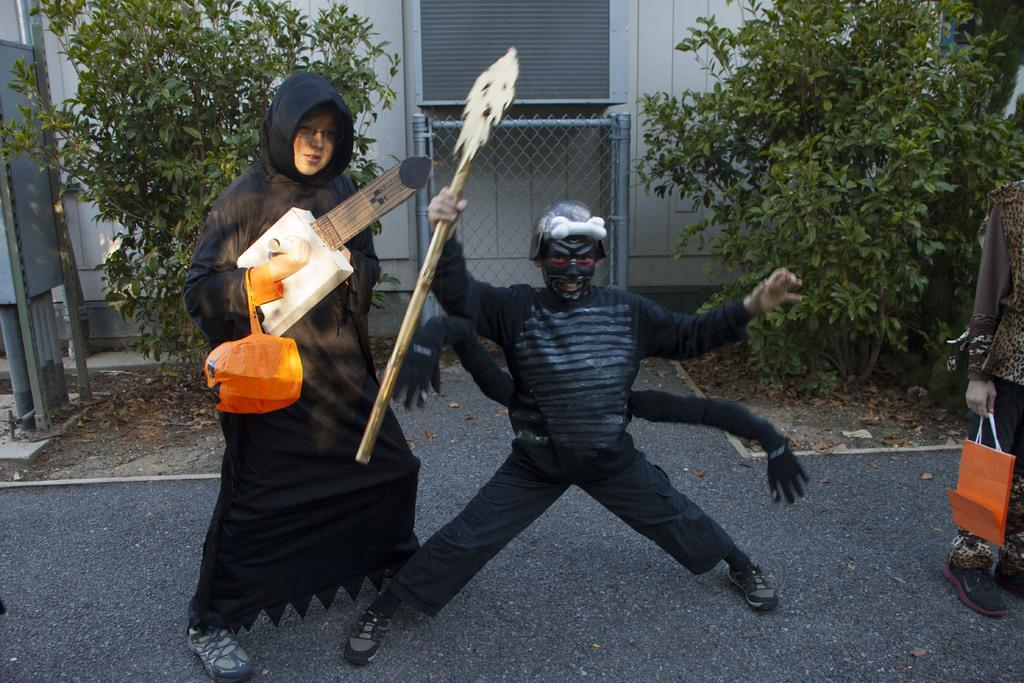How many people are in the image? There are two persons in the image. What can be observed about their attire? The two persons are dressed in Halloween manner. What type of territory is being claimed by the horn in the image? There is no horn present in the image, so this question cannot be answered. 